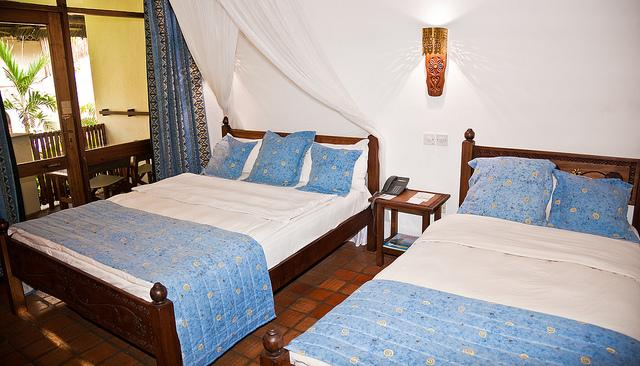What size are these beds?

Choices:
A) twin
B) king
C) full size
D) queen full size 